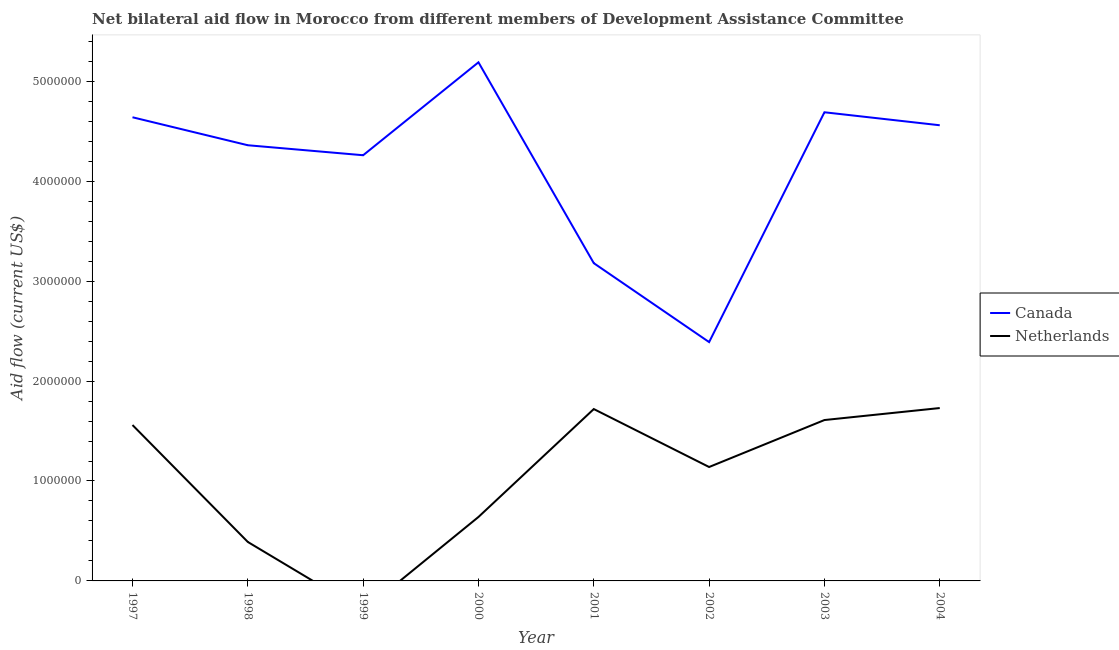How many different coloured lines are there?
Provide a succinct answer. 2. Does the line corresponding to amount of aid given by canada intersect with the line corresponding to amount of aid given by netherlands?
Make the answer very short. No. What is the amount of aid given by netherlands in 2001?
Offer a terse response. 1.72e+06. Across all years, what is the maximum amount of aid given by netherlands?
Make the answer very short. 1.73e+06. Across all years, what is the minimum amount of aid given by canada?
Make the answer very short. 2.39e+06. In which year was the amount of aid given by netherlands maximum?
Your answer should be compact. 2004. What is the total amount of aid given by netherlands in the graph?
Make the answer very short. 8.79e+06. What is the difference between the amount of aid given by netherlands in 2001 and that in 2003?
Give a very brief answer. 1.10e+05. What is the difference between the amount of aid given by canada in 2002 and the amount of aid given by netherlands in 2000?
Provide a short and direct response. 1.75e+06. What is the average amount of aid given by canada per year?
Your response must be concise. 4.16e+06. In the year 1997, what is the difference between the amount of aid given by canada and amount of aid given by netherlands?
Give a very brief answer. 3.08e+06. In how many years, is the amount of aid given by netherlands greater than 4400000 US$?
Make the answer very short. 0. What is the ratio of the amount of aid given by canada in 1999 to that in 2003?
Make the answer very short. 0.91. Is the amount of aid given by canada in 1999 less than that in 2002?
Your answer should be very brief. No. What is the difference between the highest and the second highest amount of aid given by canada?
Ensure brevity in your answer.  5.00e+05. What is the difference between the highest and the lowest amount of aid given by netherlands?
Your answer should be very brief. 1.73e+06. Is the sum of the amount of aid given by canada in 2001 and 2003 greater than the maximum amount of aid given by netherlands across all years?
Keep it short and to the point. Yes. Does the amount of aid given by netherlands monotonically increase over the years?
Your answer should be very brief. No. Is the amount of aid given by netherlands strictly greater than the amount of aid given by canada over the years?
Make the answer very short. No. Is the amount of aid given by canada strictly less than the amount of aid given by netherlands over the years?
Provide a succinct answer. No. How many lines are there?
Keep it short and to the point. 2. Are the values on the major ticks of Y-axis written in scientific E-notation?
Offer a very short reply. No. Where does the legend appear in the graph?
Provide a succinct answer. Center right. How many legend labels are there?
Offer a very short reply. 2. What is the title of the graph?
Your response must be concise. Net bilateral aid flow in Morocco from different members of Development Assistance Committee. Does "Health Care" appear as one of the legend labels in the graph?
Provide a succinct answer. No. What is the Aid flow (current US$) of Canada in 1997?
Make the answer very short. 4.64e+06. What is the Aid flow (current US$) of Netherlands in 1997?
Offer a terse response. 1.56e+06. What is the Aid flow (current US$) of Canada in 1998?
Your answer should be very brief. 4.36e+06. What is the Aid flow (current US$) of Netherlands in 1998?
Provide a short and direct response. 3.90e+05. What is the Aid flow (current US$) of Canada in 1999?
Keep it short and to the point. 4.26e+06. What is the Aid flow (current US$) in Netherlands in 1999?
Make the answer very short. 0. What is the Aid flow (current US$) in Canada in 2000?
Keep it short and to the point. 5.19e+06. What is the Aid flow (current US$) in Netherlands in 2000?
Your answer should be compact. 6.40e+05. What is the Aid flow (current US$) of Canada in 2001?
Offer a terse response. 3.18e+06. What is the Aid flow (current US$) of Netherlands in 2001?
Provide a succinct answer. 1.72e+06. What is the Aid flow (current US$) in Canada in 2002?
Provide a succinct answer. 2.39e+06. What is the Aid flow (current US$) of Netherlands in 2002?
Offer a very short reply. 1.14e+06. What is the Aid flow (current US$) in Canada in 2003?
Your answer should be very brief. 4.69e+06. What is the Aid flow (current US$) in Netherlands in 2003?
Your response must be concise. 1.61e+06. What is the Aid flow (current US$) in Canada in 2004?
Make the answer very short. 4.56e+06. What is the Aid flow (current US$) in Netherlands in 2004?
Provide a short and direct response. 1.73e+06. Across all years, what is the maximum Aid flow (current US$) in Canada?
Your answer should be very brief. 5.19e+06. Across all years, what is the maximum Aid flow (current US$) in Netherlands?
Provide a short and direct response. 1.73e+06. Across all years, what is the minimum Aid flow (current US$) in Canada?
Ensure brevity in your answer.  2.39e+06. What is the total Aid flow (current US$) of Canada in the graph?
Your answer should be compact. 3.33e+07. What is the total Aid flow (current US$) in Netherlands in the graph?
Your answer should be very brief. 8.79e+06. What is the difference between the Aid flow (current US$) in Canada in 1997 and that in 1998?
Give a very brief answer. 2.80e+05. What is the difference between the Aid flow (current US$) in Netherlands in 1997 and that in 1998?
Your answer should be compact. 1.17e+06. What is the difference between the Aid flow (current US$) in Canada in 1997 and that in 1999?
Your response must be concise. 3.80e+05. What is the difference between the Aid flow (current US$) in Canada in 1997 and that in 2000?
Offer a terse response. -5.50e+05. What is the difference between the Aid flow (current US$) of Netherlands in 1997 and that in 2000?
Keep it short and to the point. 9.20e+05. What is the difference between the Aid flow (current US$) of Canada in 1997 and that in 2001?
Your answer should be compact. 1.46e+06. What is the difference between the Aid flow (current US$) of Canada in 1997 and that in 2002?
Provide a succinct answer. 2.25e+06. What is the difference between the Aid flow (current US$) of Canada in 1998 and that in 2000?
Your answer should be compact. -8.30e+05. What is the difference between the Aid flow (current US$) in Netherlands in 1998 and that in 2000?
Provide a succinct answer. -2.50e+05. What is the difference between the Aid flow (current US$) in Canada in 1998 and that in 2001?
Provide a short and direct response. 1.18e+06. What is the difference between the Aid flow (current US$) in Netherlands in 1998 and that in 2001?
Your answer should be very brief. -1.33e+06. What is the difference between the Aid flow (current US$) of Canada in 1998 and that in 2002?
Make the answer very short. 1.97e+06. What is the difference between the Aid flow (current US$) in Netherlands in 1998 and that in 2002?
Your answer should be very brief. -7.50e+05. What is the difference between the Aid flow (current US$) of Canada in 1998 and that in 2003?
Offer a terse response. -3.30e+05. What is the difference between the Aid flow (current US$) of Netherlands in 1998 and that in 2003?
Give a very brief answer. -1.22e+06. What is the difference between the Aid flow (current US$) of Canada in 1998 and that in 2004?
Your answer should be compact. -2.00e+05. What is the difference between the Aid flow (current US$) in Netherlands in 1998 and that in 2004?
Keep it short and to the point. -1.34e+06. What is the difference between the Aid flow (current US$) of Canada in 1999 and that in 2000?
Your answer should be compact. -9.30e+05. What is the difference between the Aid flow (current US$) of Canada in 1999 and that in 2001?
Your answer should be very brief. 1.08e+06. What is the difference between the Aid flow (current US$) in Canada in 1999 and that in 2002?
Your response must be concise. 1.87e+06. What is the difference between the Aid flow (current US$) in Canada in 1999 and that in 2003?
Provide a succinct answer. -4.30e+05. What is the difference between the Aid flow (current US$) in Canada in 1999 and that in 2004?
Your answer should be compact. -3.00e+05. What is the difference between the Aid flow (current US$) in Canada in 2000 and that in 2001?
Offer a terse response. 2.01e+06. What is the difference between the Aid flow (current US$) in Netherlands in 2000 and that in 2001?
Keep it short and to the point. -1.08e+06. What is the difference between the Aid flow (current US$) in Canada in 2000 and that in 2002?
Ensure brevity in your answer.  2.80e+06. What is the difference between the Aid flow (current US$) in Netherlands in 2000 and that in 2002?
Offer a terse response. -5.00e+05. What is the difference between the Aid flow (current US$) of Canada in 2000 and that in 2003?
Make the answer very short. 5.00e+05. What is the difference between the Aid flow (current US$) in Netherlands in 2000 and that in 2003?
Ensure brevity in your answer.  -9.70e+05. What is the difference between the Aid flow (current US$) of Canada in 2000 and that in 2004?
Your answer should be very brief. 6.30e+05. What is the difference between the Aid flow (current US$) of Netherlands in 2000 and that in 2004?
Ensure brevity in your answer.  -1.09e+06. What is the difference between the Aid flow (current US$) in Canada in 2001 and that in 2002?
Offer a terse response. 7.90e+05. What is the difference between the Aid flow (current US$) of Netherlands in 2001 and that in 2002?
Your answer should be compact. 5.80e+05. What is the difference between the Aid flow (current US$) in Canada in 2001 and that in 2003?
Give a very brief answer. -1.51e+06. What is the difference between the Aid flow (current US$) in Canada in 2001 and that in 2004?
Make the answer very short. -1.38e+06. What is the difference between the Aid flow (current US$) of Netherlands in 2001 and that in 2004?
Provide a short and direct response. -10000. What is the difference between the Aid flow (current US$) in Canada in 2002 and that in 2003?
Offer a very short reply. -2.30e+06. What is the difference between the Aid flow (current US$) in Netherlands in 2002 and that in 2003?
Your response must be concise. -4.70e+05. What is the difference between the Aid flow (current US$) in Canada in 2002 and that in 2004?
Your answer should be very brief. -2.17e+06. What is the difference between the Aid flow (current US$) of Netherlands in 2002 and that in 2004?
Offer a very short reply. -5.90e+05. What is the difference between the Aid flow (current US$) of Canada in 1997 and the Aid flow (current US$) of Netherlands in 1998?
Your response must be concise. 4.25e+06. What is the difference between the Aid flow (current US$) in Canada in 1997 and the Aid flow (current US$) in Netherlands in 2001?
Your response must be concise. 2.92e+06. What is the difference between the Aid flow (current US$) of Canada in 1997 and the Aid flow (current US$) of Netherlands in 2002?
Give a very brief answer. 3.50e+06. What is the difference between the Aid flow (current US$) of Canada in 1997 and the Aid flow (current US$) of Netherlands in 2003?
Keep it short and to the point. 3.03e+06. What is the difference between the Aid flow (current US$) in Canada in 1997 and the Aid flow (current US$) in Netherlands in 2004?
Your answer should be very brief. 2.91e+06. What is the difference between the Aid flow (current US$) in Canada in 1998 and the Aid flow (current US$) in Netherlands in 2000?
Offer a very short reply. 3.72e+06. What is the difference between the Aid flow (current US$) of Canada in 1998 and the Aid flow (current US$) of Netherlands in 2001?
Keep it short and to the point. 2.64e+06. What is the difference between the Aid flow (current US$) of Canada in 1998 and the Aid flow (current US$) of Netherlands in 2002?
Your answer should be compact. 3.22e+06. What is the difference between the Aid flow (current US$) in Canada in 1998 and the Aid flow (current US$) in Netherlands in 2003?
Provide a short and direct response. 2.75e+06. What is the difference between the Aid flow (current US$) in Canada in 1998 and the Aid flow (current US$) in Netherlands in 2004?
Keep it short and to the point. 2.63e+06. What is the difference between the Aid flow (current US$) in Canada in 1999 and the Aid flow (current US$) in Netherlands in 2000?
Your answer should be very brief. 3.62e+06. What is the difference between the Aid flow (current US$) of Canada in 1999 and the Aid flow (current US$) of Netherlands in 2001?
Your response must be concise. 2.54e+06. What is the difference between the Aid flow (current US$) in Canada in 1999 and the Aid flow (current US$) in Netherlands in 2002?
Offer a very short reply. 3.12e+06. What is the difference between the Aid flow (current US$) of Canada in 1999 and the Aid flow (current US$) of Netherlands in 2003?
Offer a very short reply. 2.65e+06. What is the difference between the Aid flow (current US$) in Canada in 1999 and the Aid flow (current US$) in Netherlands in 2004?
Give a very brief answer. 2.53e+06. What is the difference between the Aid flow (current US$) of Canada in 2000 and the Aid flow (current US$) of Netherlands in 2001?
Provide a succinct answer. 3.47e+06. What is the difference between the Aid flow (current US$) of Canada in 2000 and the Aid flow (current US$) of Netherlands in 2002?
Your answer should be very brief. 4.05e+06. What is the difference between the Aid flow (current US$) in Canada in 2000 and the Aid flow (current US$) in Netherlands in 2003?
Your response must be concise. 3.58e+06. What is the difference between the Aid flow (current US$) of Canada in 2000 and the Aid flow (current US$) of Netherlands in 2004?
Provide a short and direct response. 3.46e+06. What is the difference between the Aid flow (current US$) in Canada in 2001 and the Aid flow (current US$) in Netherlands in 2002?
Your answer should be compact. 2.04e+06. What is the difference between the Aid flow (current US$) of Canada in 2001 and the Aid flow (current US$) of Netherlands in 2003?
Offer a terse response. 1.57e+06. What is the difference between the Aid flow (current US$) in Canada in 2001 and the Aid flow (current US$) in Netherlands in 2004?
Your answer should be compact. 1.45e+06. What is the difference between the Aid flow (current US$) of Canada in 2002 and the Aid flow (current US$) of Netherlands in 2003?
Your response must be concise. 7.80e+05. What is the difference between the Aid flow (current US$) of Canada in 2003 and the Aid flow (current US$) of Netherlands in 2004?
Your answer should be very brief. 2.96e+06. What is the average Aid flow (current US$) of Canada per year?
Your answer should be very brief. 4.16e+06. What is the average Aid flow (current US$) in Netherlands per year?
Provide a succinct answer. 1.10e+06. In the year 1997, what is the difference between the Aid flow (current US$) in Canada and Aid flow (current US$) in Netherlands?
Your answer should be compact. 3.08e+06. In the year 1998, what is the difference between the Aid flow (current US$) in Canada and Aid flow (current US$) in Netherlands?
Give a very brief answer. 3.97e+06. In the year 2000, what is the difference between the Aid flow (current US$) of Canada and Aid flow (current US$) of Netherlands?
Your answer should be very brief. 4.55e+06. In the year 2001, what is the difference between the Aid flow (current US$) of Canada and Aid flow (current US$) of Netherlands?
Offer a terse response. 1.46e+06. In the year 2002, what is the difference between the Aid flow (current US$) in Canada and Aid flow (current US$) in Netherlands?
Keep it short and to the point. 1.25e+06. In the year 2003, what is the difference between the Aid flow (current US$) of Canada and Aid flow (current US$) of Netherlands?
Keep it short and to the point. 3.08e+06. In the year 2004, what is the difference between the Aid flow (current US$) of Canada and Aid flow (current US$) of Netherlands?
Your response must be concise. 2.83e+06. What is the ratio of the Aid flow (current US$) in Canada in 1997 to that in 1998?
Ensure brevity in your answer.  1.06. What is the ratio of the Aid flow (current US$) in Canada in 1997 to that in 1999?
Make the answer very short. 1.09. What is the ratio of the Aid flow (current US$) of Canada in 1997 to that in 2000?
Ensure brevity in your answer.  0.89. What is the ratio of the Aid flow (current US$) in Netherlands in 1997 to that in 2000?
Ensure brevity in your answer.  2.44. What is the ratio of the Aid flow (current US$) of Canada in 1997 to that in 2001?
Provide a succinct answer. 1.46. What is the ratio of the Aid flow (current US$) of Netherlands in 1997 to that in 2001?
Provide a succinct answer. 0.91. What is the ratio of the Aid flow (current US$) of Canada in 1997 to that in 2002?
Offer a very short reply. 1.94. What is the ratio of the Aid flow (current US$) of Netherlands in 1997 to that in 2002?
Your response must be concise. 1.37. What is the ratio of the Aid flow (current US$) in Canada in 1997 to that in 2003?
Your answer should be very brief. 0.99. What is the ratio of the Aid flow (current US$) in Netherlands in 1997 to that in 2003?
Provide a short and direct response. 0.97. What is the ratio of the Aid flow (current US$) in Canada in 1997 to that in 2004?
Your answer should be compact. 1.02. What is the ratio of the Aid flow (current US$) in Netherlands in 1997 to that in 2004?
Give a very brief answer. 0.9. What is the ratio of the Aid flow (current US$) in Canada in 1998 to that in 1999?
Provide a succinct answer. 1.02. What is the ratio of the Aid flow (current US$) of Canada in 1998 to that in 2000?
Give a very brief answer. 0.84. What is the ratio of the Aid flow (current US$) in Netherlands in 1998 to that in 2000?
Give a very brief answer. 0.61. What is the ratio of the Aid flow (current US$) of Canada in 1998 to that in 2001?
Keep it short and to the point. 1.37. What is the ratio of the Aid flow (current US$) in Netherlands in 1998 to that in 2001?
Ensure brevity in your answer.  0.23. What is the ratio of the Aid flow (current US$) of Canada in 1998 to that in 2002?
Your answer should be compact. 1.82. What is the ratio of the Aid flow (current US$) of Netherlands in 1998 to that in 2002?
Keep it short and to the point. 0.34. What is the ratio of the Aid flow (current US$) of Canada in 1998 to that in 2003?
Ensure brevity in your answer.  0.93. What is the ratio of the Aid flow (current US$) of Netherlands in 1998 to that in 2003?
Offer a terse response. 0.24. What is the ratio of the Aid flow (current US$) in Canada in 1998 to that in 2004?
Offer a very short reply. 0.96. What is the ratio of the Aid flow (current US$) of Netherlands in 1998 to that in 2004?
Give a very brief answer. 0.23. What is the ratio of the Aid flow (current US$) in Canada in 1999 to that in 2000?
Your answer should be very brief. 0.82. What is the ratio of the Aid flow (current US$) in Canada in 1999 to that in 2001?
Give a very brief answer. 1.34. What is the ratio of the Aid flow (current US$) of Canada in 1999 to that in 2002?
Your response must be concise. 1.78. What is the ratio of the Aid flow (current US$) of Canada in 1999 to that in 2003?
Ensure brevity in your answer.  0.91. What is the ratio of the Aid flow (current US$) of Canada in 1999 to that in 2004?
Ensure brevity in your answer.  0.93. What is the ratio of the Aid flow (current US$) of Canada in 2000 to that in 2001?
Your response must be concise. 1.63. What is the ratio of the Aid flow (current US$) of Netherlands in 2000 to that in 2001?
Your answer should be very brief. 0.37. What is the ratio of the Aid flow (current US$) in Canada in 2000 to that in 2002?
Make the answer very short. 2.17. What is the ratio of the Aid flow (current US$) in Netherlands in 2000 to that in 2002?
Offer a very short reply. 0.56. What is the ratio of the Aid flow (current US$) in Canada in 2000 to that in 2003?
Make the answer very short. 1.11. What is the ratio of the Aid flow (current US$) in Netherlands in 2000 to that in 2003?
Make the answer very short. 0.4. What is the ratio of the Aid flow (current US$) in Canada in 2000 to that in 2004?
Offer a very short reply. 1.14. What is the ratio of the Aid flow (current US$) in Netherlands in 2000 to that in 2004?
Offer a very short reply. 0.37. What is the ratio of the Aid flow (current US$) in Canada in 2001 to that in 2002?
Provide a succinct answer. 1.33. What is the ratio of the Aid flow (current US$) in Netherlands in 2001 to that in 2002?
Offer a terse response. 1.51. What is the ratio of the Aid flow (current US$) of Canada in 2001 to that in 2003?
Offer a terse response. 0.68. What is the ratio of the Aid flow (current US$) of Netherlands in 2001 to that in 2003?
Your answer should be very brief. 1.07. What is the ratio of the Aid flow (current US$) of Canada in 2001 to that in 2004?
Give a very brief answer. 0.7. What is the ratio of the Aid flow (current US$) in Netherlands in 2001 to that in 2004?
Your response must be concise. 0.99. What is the ratio of the Aid flow (current US$) of Canada in 2002 to that in 2003?
Give a very brief answer. 0.51. What is the ratio of the Aid flow (current US$) of Netherlands in 2002 to that in 2003?
Your response must be concise. 0.71. What is the ratio of the Aid flow (current US$) in Canada in 2002 to that in 2004?
Your answer should be compact. 0.52. What is the ratio of the Aid flow (current US$) in Netherlands in 2002 to that in 2004?
Give a very brief answer. 0.66. What is the ratio of the Aid flow (current US$) in Canada in 2003 to that in 2004?
Provide a short and direct response. 1.03. What is the ratio of the Aid flow (current US$) of Netherlands in 2003 to that in 2004?
Ensure brevity in your answer.  0.93. What is the difference between the highest and the second highest Aid flow (current US$) of Netherlands?
Give a very brief answer. 10000. What is the difference between the highest and the lowest Aid flow (current US$) in Canada?
Your response must be concise. 2.80e+06. What is the difference between the highest and the lowest Aid flow (current US$) in Netherlands?
Ensure brevity in your answer.  1.73e+06. 